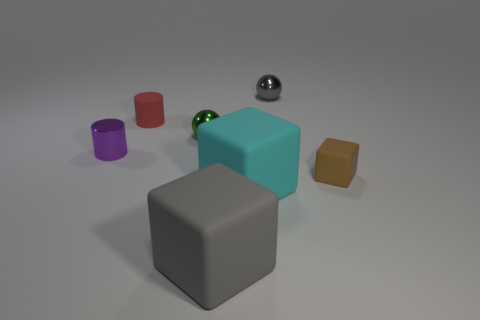How many other objects are the same material as the purple cylinder?
Offer a terse response. 2. There is a purple thing that is the same material as the small green thing; what shape is it?
Provide a short and direct response. Cylinder. Is there any other thing that is the same color as the tiny rubber cube?
Provide a succinct answer. No. Are there more small brown objects that are behind the small purple shiny object than large gray spheres?
Your response must be concise. No. Is the shape of the big cyan matte object the same as the rubber thing that is left of the big gray cube?
Your answer should be very brief. No. What number of other rubber things are the same size as the red matte thing?
Your answer should be compact. 1. There is a small thing in front of the small cylinder that is in front of the green ball; what number of tiny brown matte objects are in front of it?
Provide a succinct answer. 0. Is the number of brown rubber cubes to the left of the purple cylinder the same as the number of blocks that are to the right of the small rubber cube?
Provide a succinct answer. Yes. How many big cyan rubber objects have the same shape as the brown object?
Provide a short and direct response. 1. Are there any large gray blocks made of the same material as the small purple object?
Keep it short and to the point. No. 